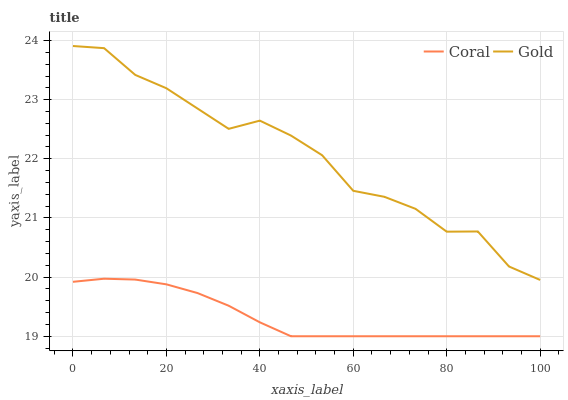Does Coral have the minimum area under the curve?
Answer yes or no. Yes. Does Gold have the maximum area under the curve?
Answer yes or no. Yes. Does Gold have the minimum area under the curve?
Answer yes or no. No. Is Coral the smoothest?
Answer yes or no. Yes. Is Gold the roughest?
Answer yes or no. Yes. Is Gold the smoothest?
Answer yes or no. No. Does Gold have the lowest value?
Answer yes or no. No. Does Gold have the highest value?
Answer yes or no. Yes. Is Coral less than Gold?
Answer yes or no. Yes. Is Gold greater than Coral?
Answer yes or no. Yes. Does Coral intersect Gold?
Answer yes or no. No. 